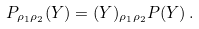<formula> <loc_0><loc_0><loc_500><loc_500>P _ { \rho _ { 1 } \rho _ { 2 } } ( Y ) = ( Y ) _ { \rho _ { 1 } \rho _ { 2 } } P ( Y ) \, .</formula> 